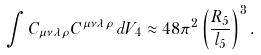<formula> <loc_0><loc_0><loc_500><loc_500>\int C _ { \mu \nu \lambda \rho } C ^ { \mu \nu \lambda \rho } \, d V _ { 4 } \approx 4 8 \pi ^ { 2 } \left ( \frac { R _ { 5 } } { l _ { 5 } } \right ) ^ { 3 } .</formula> 